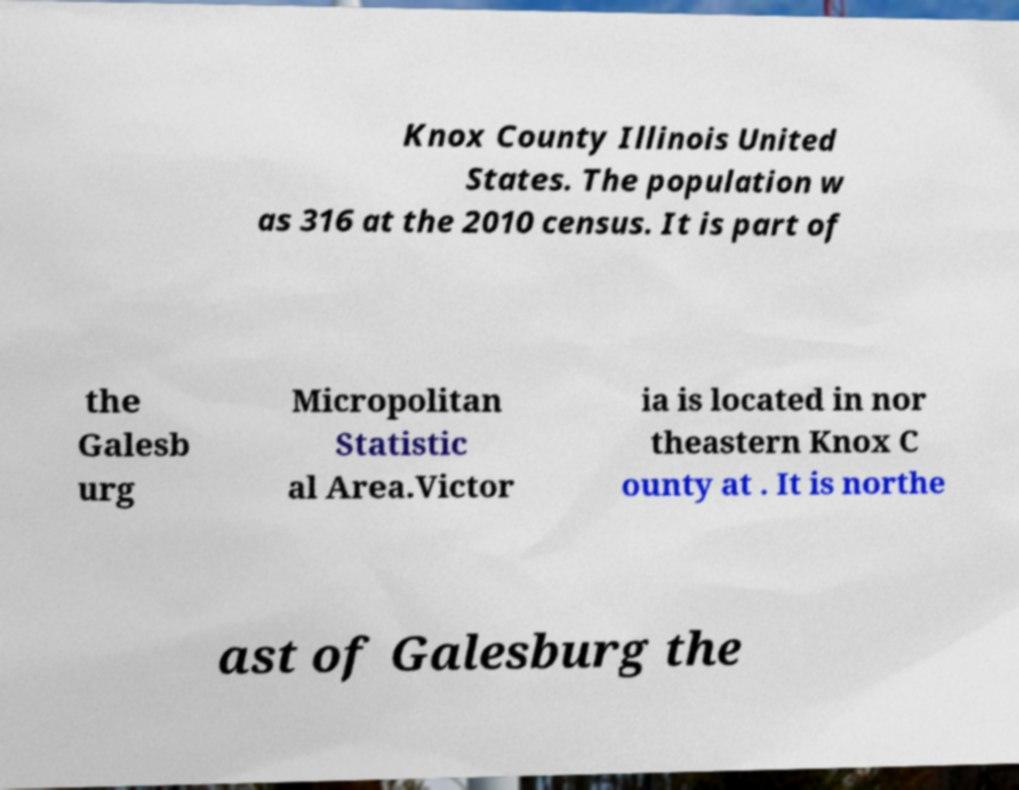Please read and relay the text visible in this image. What does it say? Knox County Illinois United States. The population w as 316 at the 2010 census. It is part of the Galesb urg Micropolitan Statistic al Area.Victor ia is located in nor theastern Knox C ounty at . It is northe ast of Galesburg the 